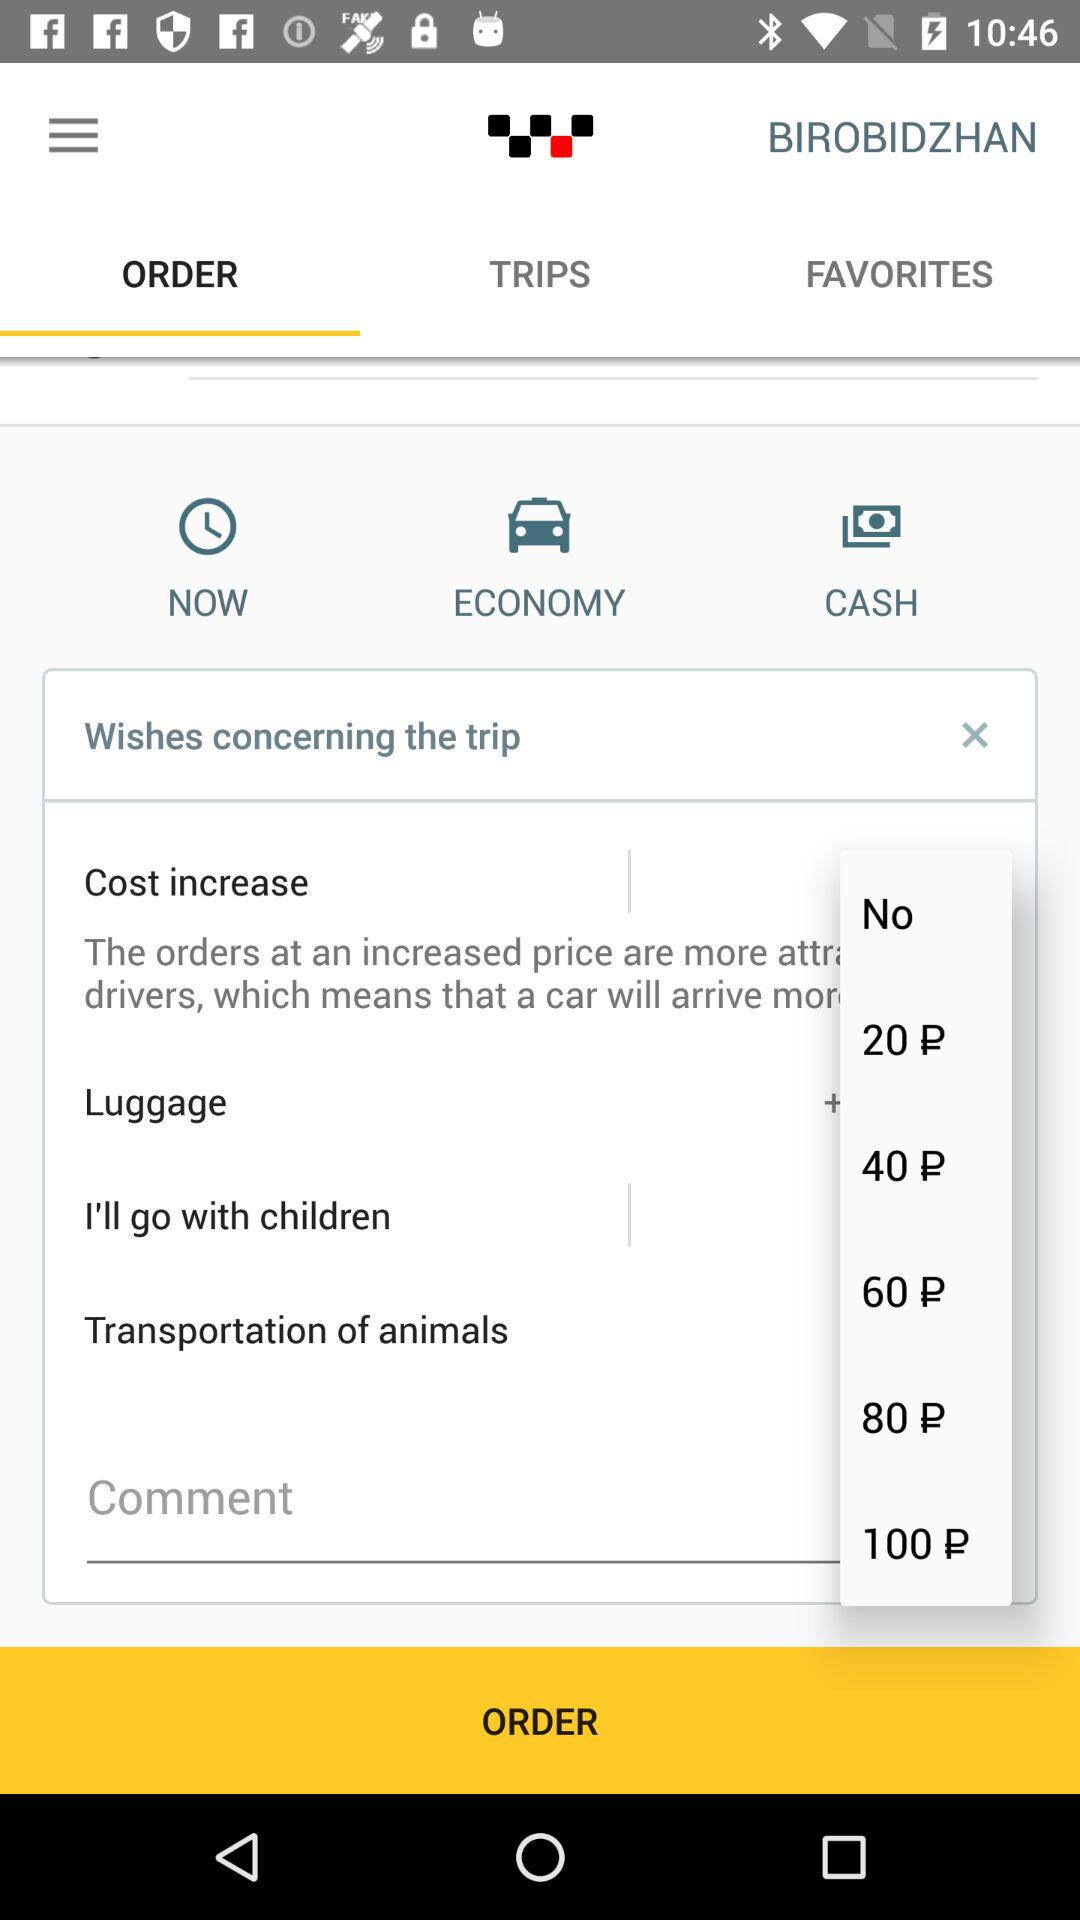How much more does it cost to have luggage than to have children?
Answer the question using a single word or phrase. 20 